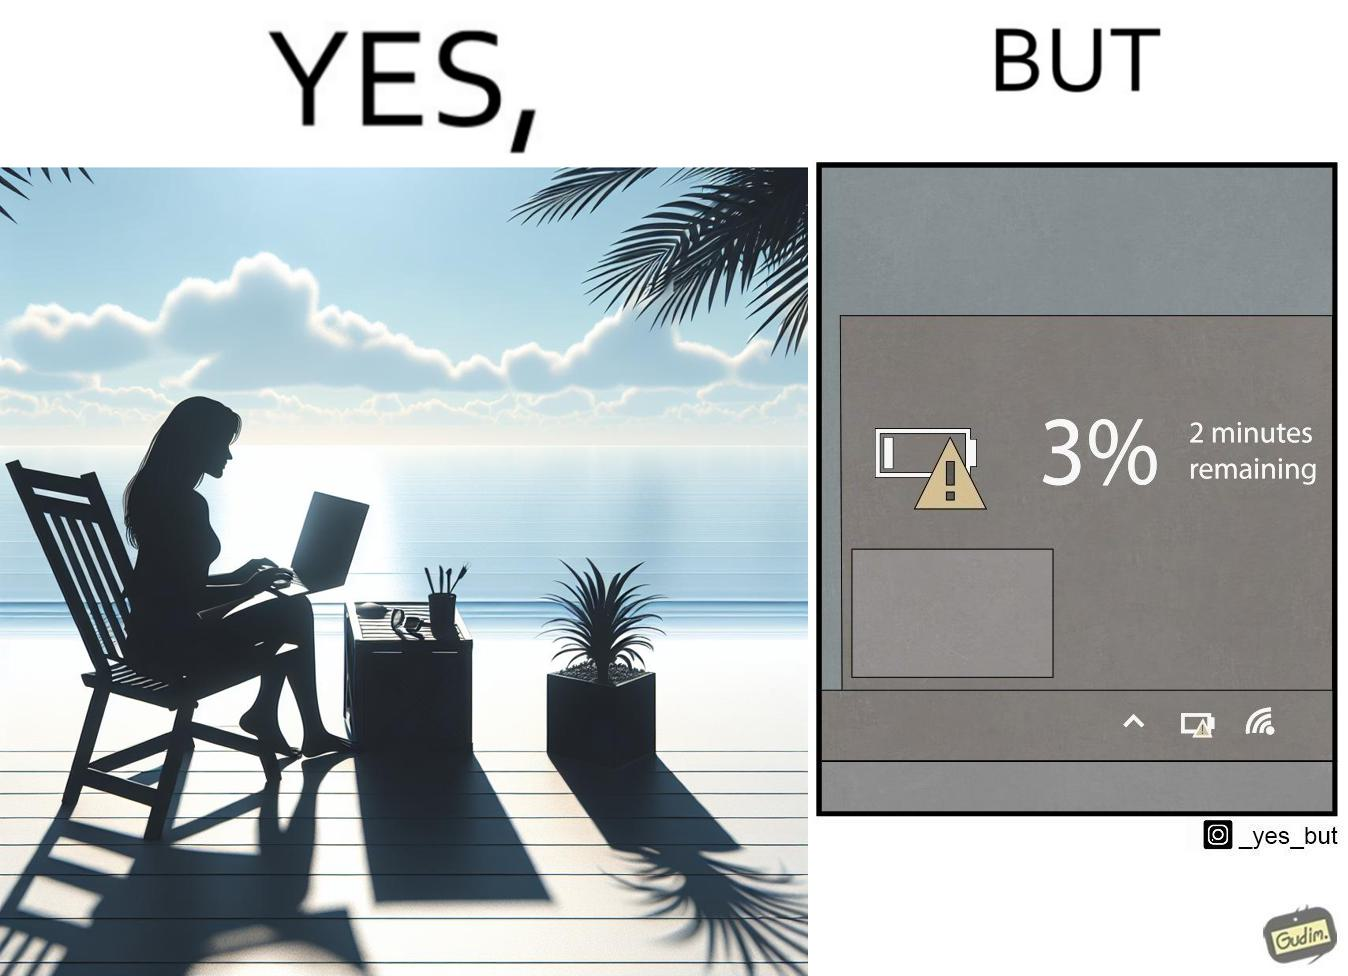What do you see in each half of this image? In the left part of the image: A person sitting in a chair in a beach by the sea shore while working on a laptop. In the right part of the image: Low charge of battery, showing 3% charge, and an estimated time of 2 minutes remaining until the device switches off due to lack of battery charge. 